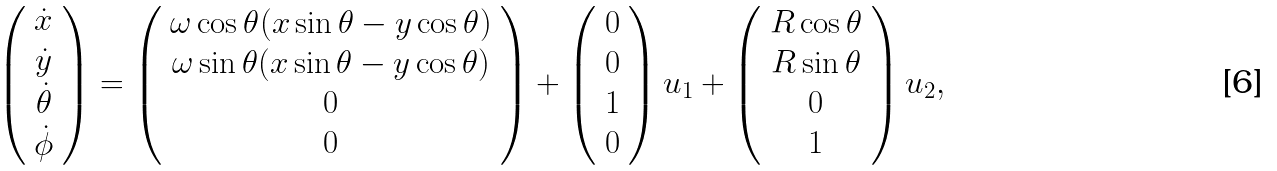<formula> <loc_0><loc_0><loc_500><loc_500>\left ( \begin{array} { c } \dot { x } \\ \dot { y } \\ \dot { \theta } \\ \dot { \phi } \\ \end{array} \right ) = \left ( \begin{array} { c } \omega \cos \theta ( x \sin \theta - y \cos \theta ) \\ \omega \sin \theta ( x \sin \theta - y \cos \theta ) \\ 0 \\ 0 \\ \end{array} \right ) + \left ( \begin{array} { c } 0 \\ 0 \\ 1 \\ 0 \\ \end{array} \right ) u _ { 1 } + \left ( \begin{array} { c } R \cos \theta \\ R \sin \theta \\ 0 \\ 1 \\ \end{array} \right ) u _ { 2 } ,</formula> 